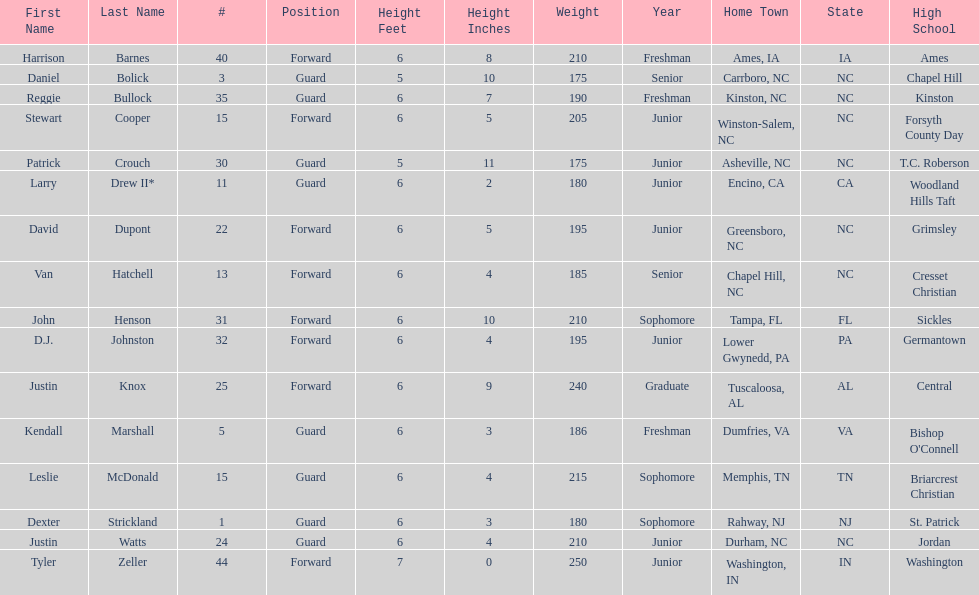Who was taller, justin knox or john henson? John Henson. 